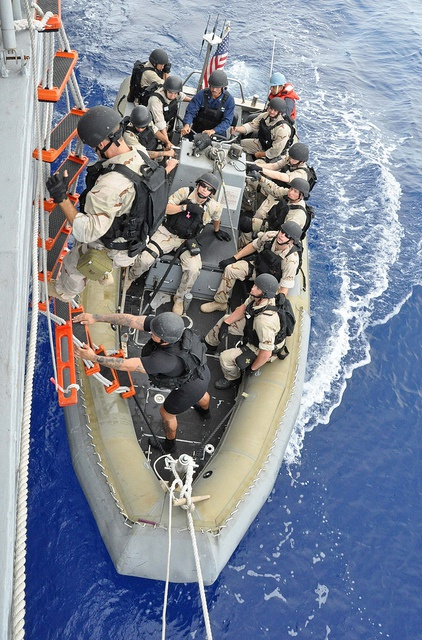Describe the objects in this image and their specific colors. I can see boat in gray, lightgray, and darkgray tones, boat in gray, darkgray, lightgray, and tan tones, people in gray, black, lightgray, and darkgray tones, people in gray, black, darkgray, and tan tones, and people in gray, black, darkgray, and lightgray tones in this image. 